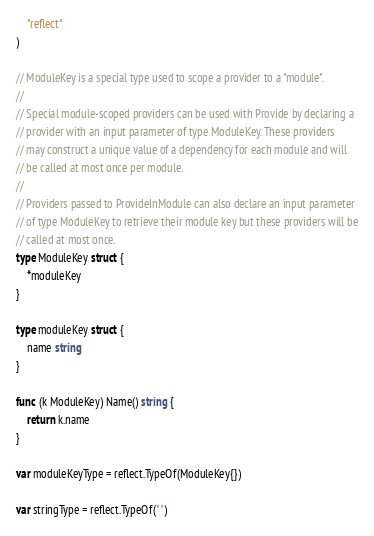Convert code to text. <code><loc_0><loc_0><loc_500><loc_500><_Go_>	"reflect"
)

// ModuleKey is a special type used to scope a provider to a "module".
//
// Special module-scoped providers can be used with Provide by declaring a
// provider with an input parameter of type ModuleKey. These providers
// may construct a unique value of a dependency for each module and will
// be called at most once per module.
//
// Providers passed to ProvideInModule can also declare an input parameter
// of type ModuleKey to retrieve their module key but these providers will be
// called at most once.
type ModuleKey struct {
	*moduleKey
}

type moduleKey struct {
	name string
}

func (k ModuleKey) Name() string {
	return k.name
}

var moduleKeyType = reflect.TypeOf(ModuleKey{})

var stringType = reflect.TypeOf("")
</code> 